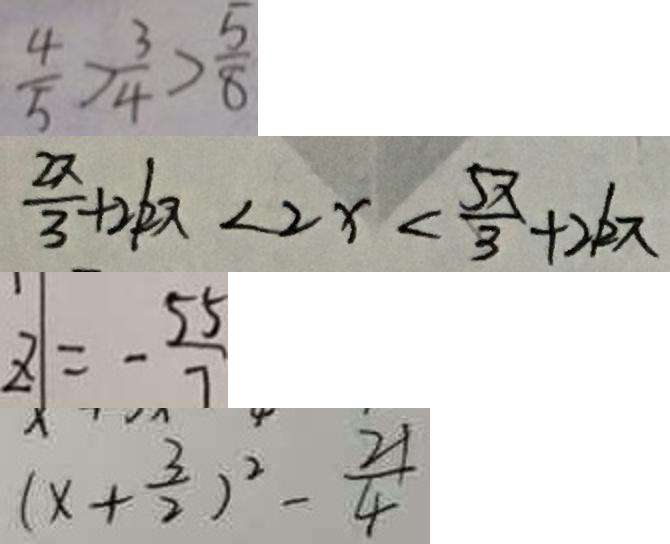Convert formula to latex. <formula><loc_0><loc_0><loc_500><loc_500>\frac { 4 } { 5 } > \frac { 3 } { 4 } > \frac { 5 } { 8 } 
 \frac { x } { 3 } + 2 k \pi < 2 x < \frac { 5 \pi } { 3 } + 2 k \pi 
 Z = - \frac { 5 5 } { 7 } 
 ( x + \frac { 3 } { 2 } ) ^ { 2 } - \frac { 2 1 } { 4 }</formula> 